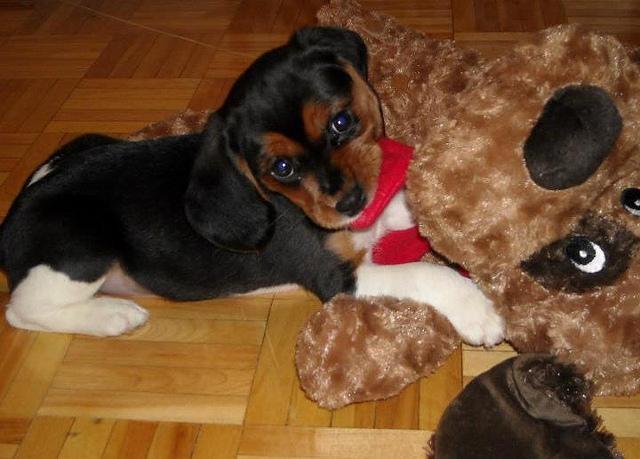How many people are wearing helmets?
Give a very brief answer. 0. 